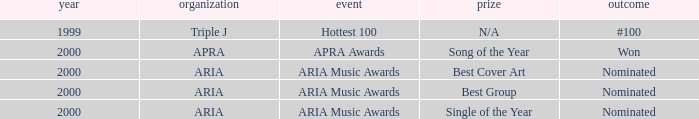What's the award for #100? N/A. 